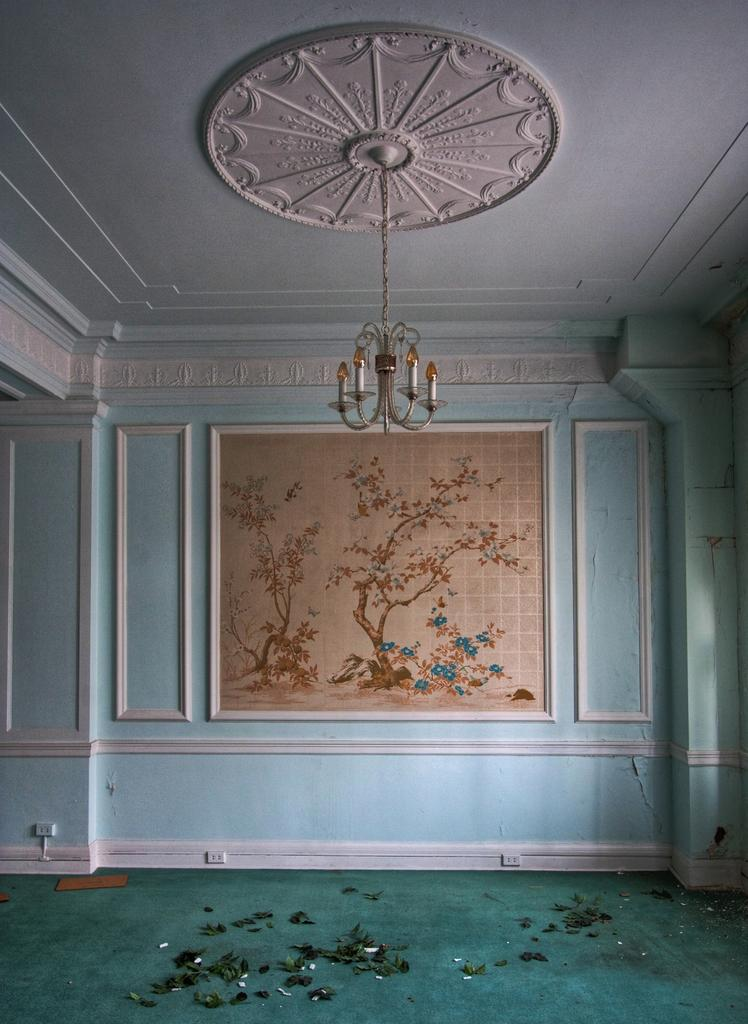What type of space is depicted in the image? The image shows an inside view of a room. What can be seen on the wall in the front of the room? There is a blue wall with a painting or photo frame in the front of the room. What type of lighting fixture is present in the room? A chandelier is hanging from the ceiling. Can you see a monkey climbing on the chandelier in the image? No, there is no monkey present in the image. What type of leaf is used as a decoration on the painting or photo frame? There is no leaf mentioned or visible on the painting or photo frame in the image. 